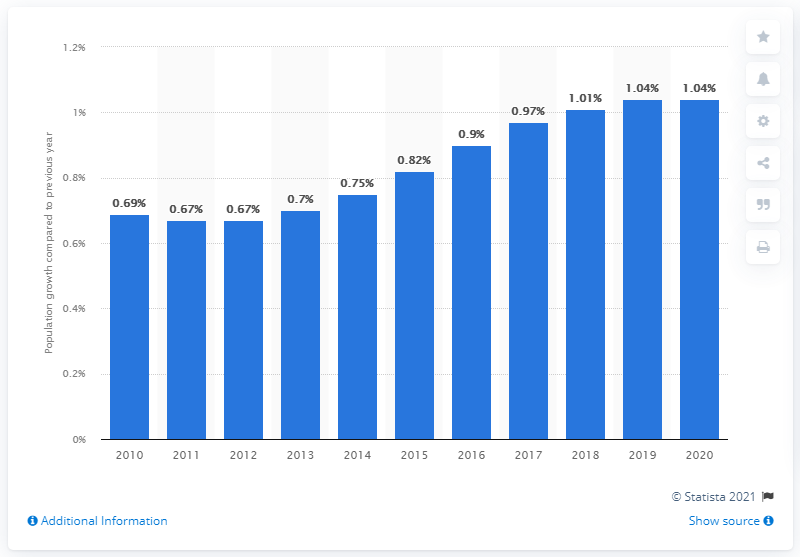Highlight a few significant elements in this photo. In 2020, the population of Swaziland decreased by 1.04%. 